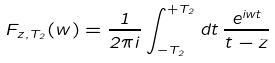Convert formula to latex. <formula><loc_0><loc_0><loc_500><loc_500>F _ { z , T _ { 2 } } ( w ) = \frac { 1 } { 2 \pi i } \int _ { - T _ { 2 } } ^ { + T _ { 2 } } d t \, \frac { e ^ { i w t } } { t - z }</formula> 